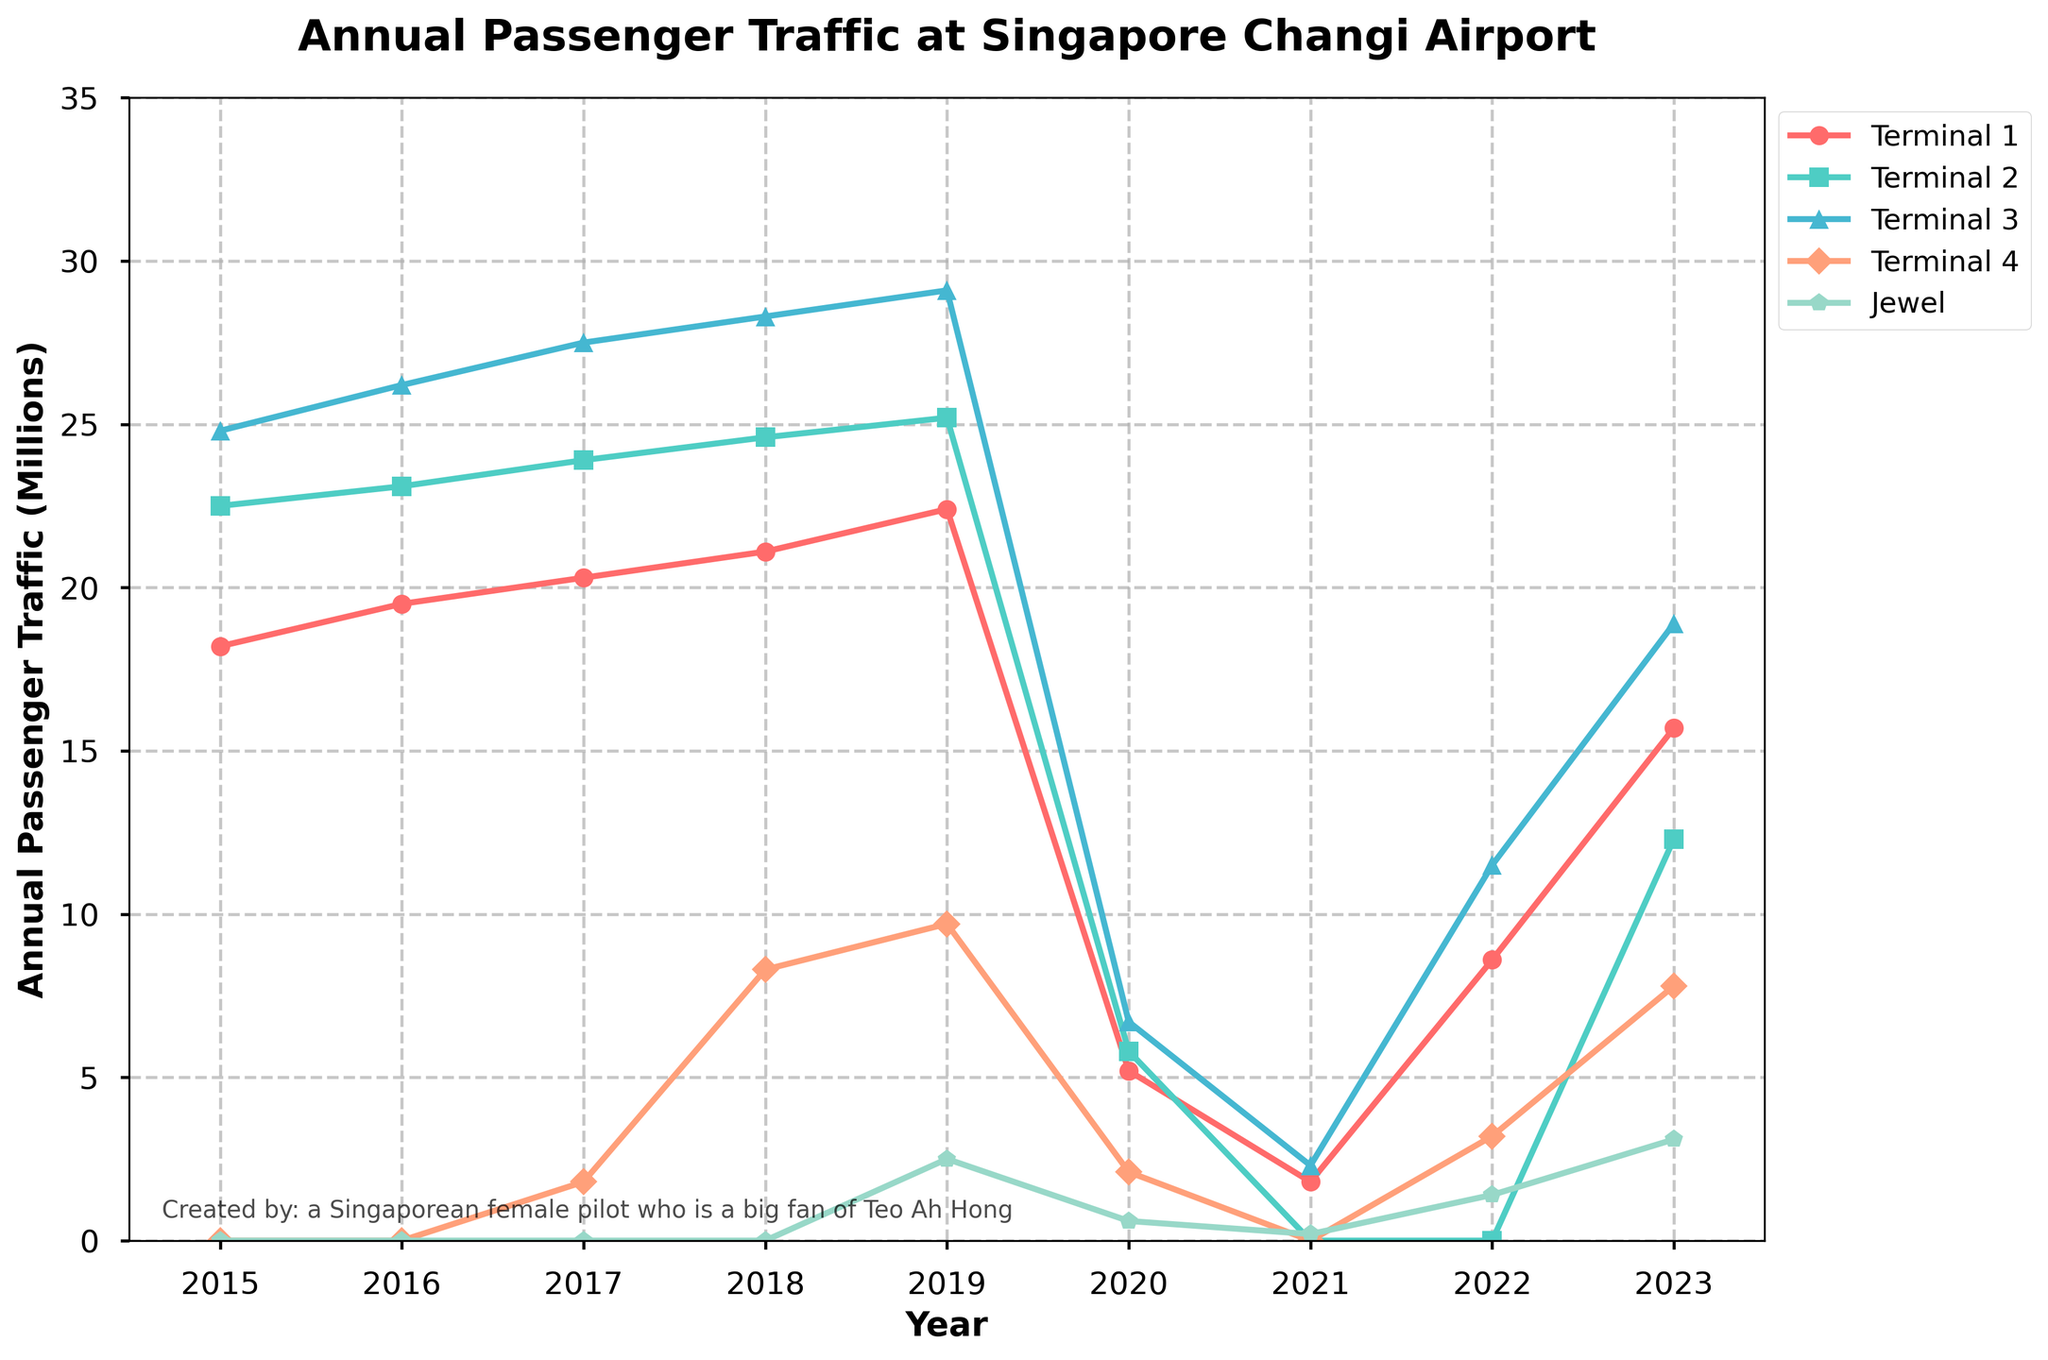What's the general trend of passenger traffic at Terminal 1 from 2015 to 2023? The passenger traffic at Terminal 1 generally increased from 2015 to 2019, faced a significant drop in 2020 due to the pandemic, then started recovering post-2021.
Answer: Increasing trend with a dip in 2020 and 2021 Which terminal had the highest passenger traffic in 2019? Looking at the passenger traffic for each terminal in 2019, Terminal 3 had the highest at 29.1 million passengers.
Answer: Terminal 3 Compare Terminal 2 and Terminal 4 in terms of passenger traffic in 2023. Which one had more? In 2023, Terminal 2 had 12.3 million passengers and Terminal 4 had 7.8 million passengers. Terminal 2 had more passenger traffic than Terminal 4.
Answer: Terminal 2 How did the opening of Jewel affect its passenger traffic from 2019 to 2023? Jewel’s passenger traffic started at 2.5 million in 2019 (the year it opened), dropped to 0.6 million in 2020, further decreased in 2021, then started to recover from 1.4 million in 2022 to 3.1 million in 2023.
Answer: Initially low, dropping during the pandemic, then gradually increasing What is the combined passenger traffic of Terminal 1 and Terminal 3 in 2023? Terminal 1 had 15.7 million passengers and Terminal 3 had 18.9 million passengers in 2023. Adding them gives a total of 15.7 + 18.9 = 34.6 million passengers.
Answer: 34.6 million Which terminal shows no passenger traffic in certain years, and which years are those? Terminal 2 shows no passenger traffic in 2021 and 2022.
Answer: Terminal 2, 2021 and 2022 What was the percentage decrease in passenger traffic at Terminal 3 from 2019 to 2020? Terminal 3 had 29.1 million passengers in 2019 and 6.7 million in 2020. The decrease is 29.1 - 6.7 = 22.4 million. The percentage decrease is (22.4 / 29.1) * 100 ≈ 77%.
Answer: Approximately 77% During which year did Terminal 4 start operating and how can you tell? Terminal 4 started operating in 2017, evidenced by the introduction of passenger traffic data for Terminal 4 starting in that year.
Answer: 2017 How did the pandemic impact the passenger traffic across all terminals in 2020? In 2020, all terminals saw a sharp drop in passenger traffic compared to 2019, with passenger numbers decreasing to roughly a fifth or less of the previous year's values.
Answer: Significant decline across all terminals Which terminal showed the quickest recovery in passenger traffic post-pandemic (2020-2023)? Terminal 1 showed a significant increase in passenger traffic from 5.2 million in 2020 to 15.7 million in 2023, indicating a quicker recovery compared to other terminals.
Answer: Terminal 1 